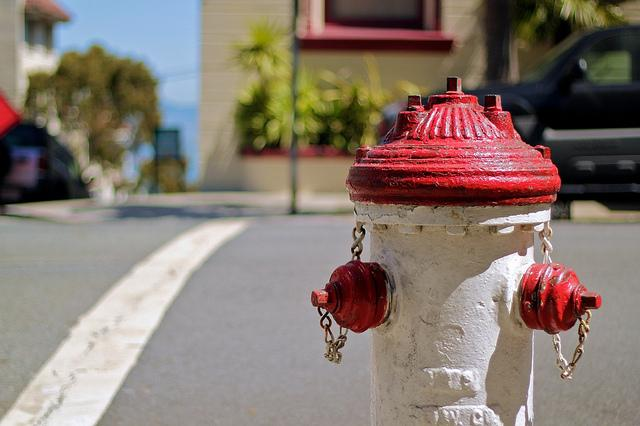What does the line near the hydrant signify? Please explain your reasoning. road intersection. A single white line is painted across a street. 